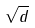Convert formula to latex. <formula><loc_0><loc_0><loc_500><loc_500>\sqrt { d }</formula> 